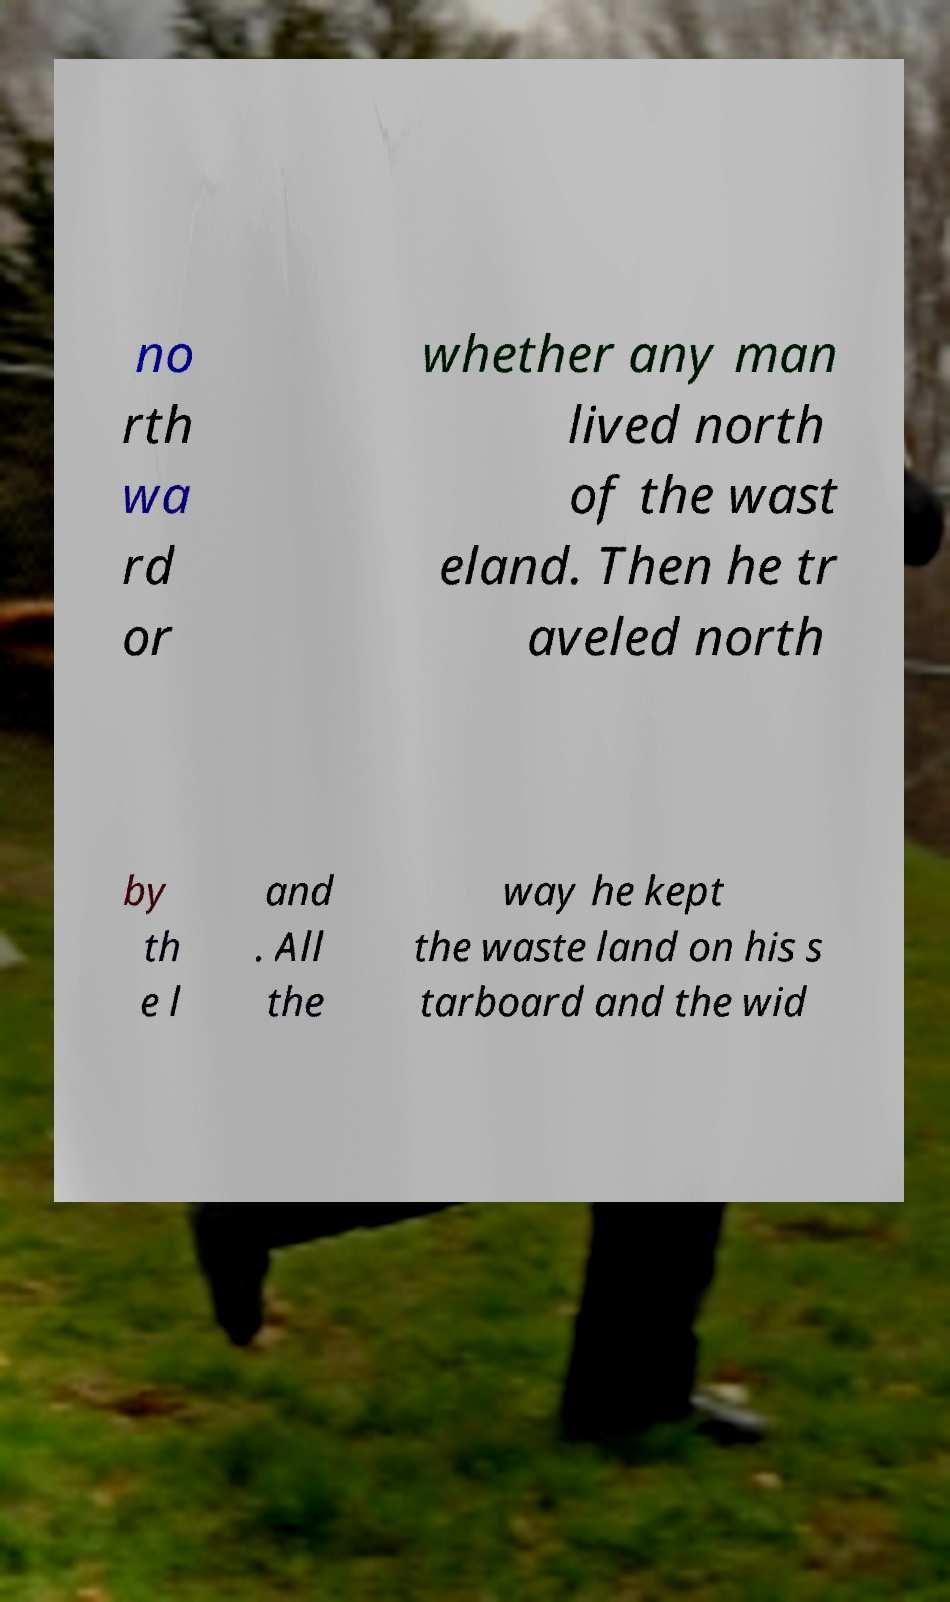What messages or text are displayed in this image? I need them in a readable, typed format. no rth wa rd or whether any man lived north of the wast eland. Then he tr aveled north by th e l and . All the way he kept the waste land on his s tarboard and the wid 